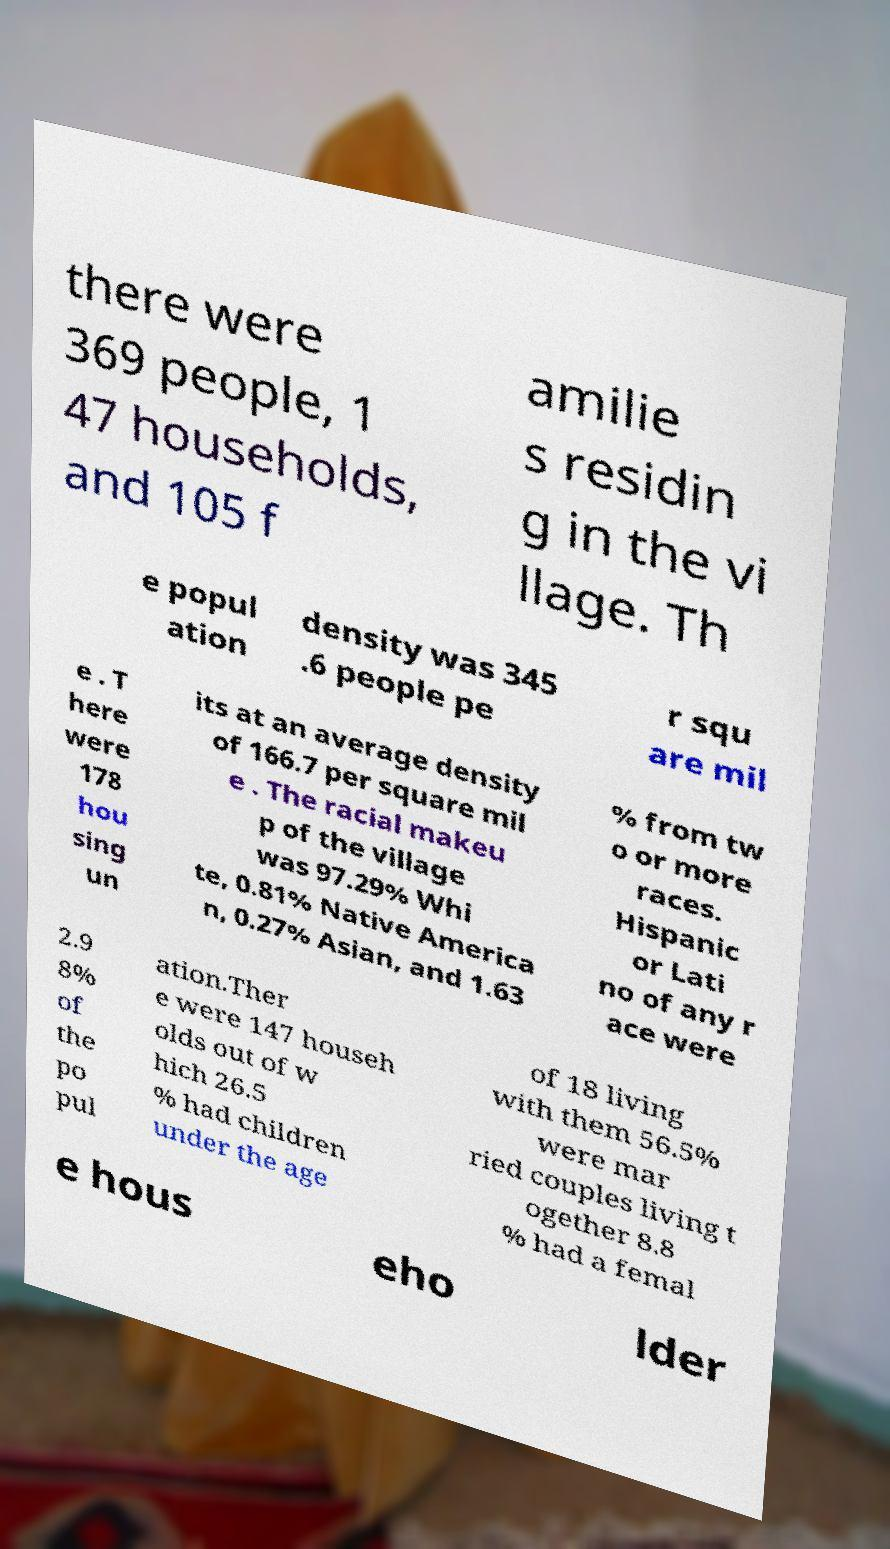Please identify and transcribe the text found in this image. there were 369 people, 1 47 households, and 105 f amilie s residin g in the vi llage. Th e popul ation density was 345 .6 people pe r squ are mil e . T here were 178 hou sing un its at an average density of 166.7 per square mil e . The racial makeu p of the village was 97.29% Whi te, 0.81% Native America n, 0.27% Asian, and 1.63 % from tw o or more races. Hispanic or Lati no of any r ace were 2.9 8% of the po pul ation.Ther e were 147 househ olds out of w hich 26.5 % had children under the age of 18 living with them 56.5% were mar ried couples living t ogether 8.8 % had a femal e hous eho lder 